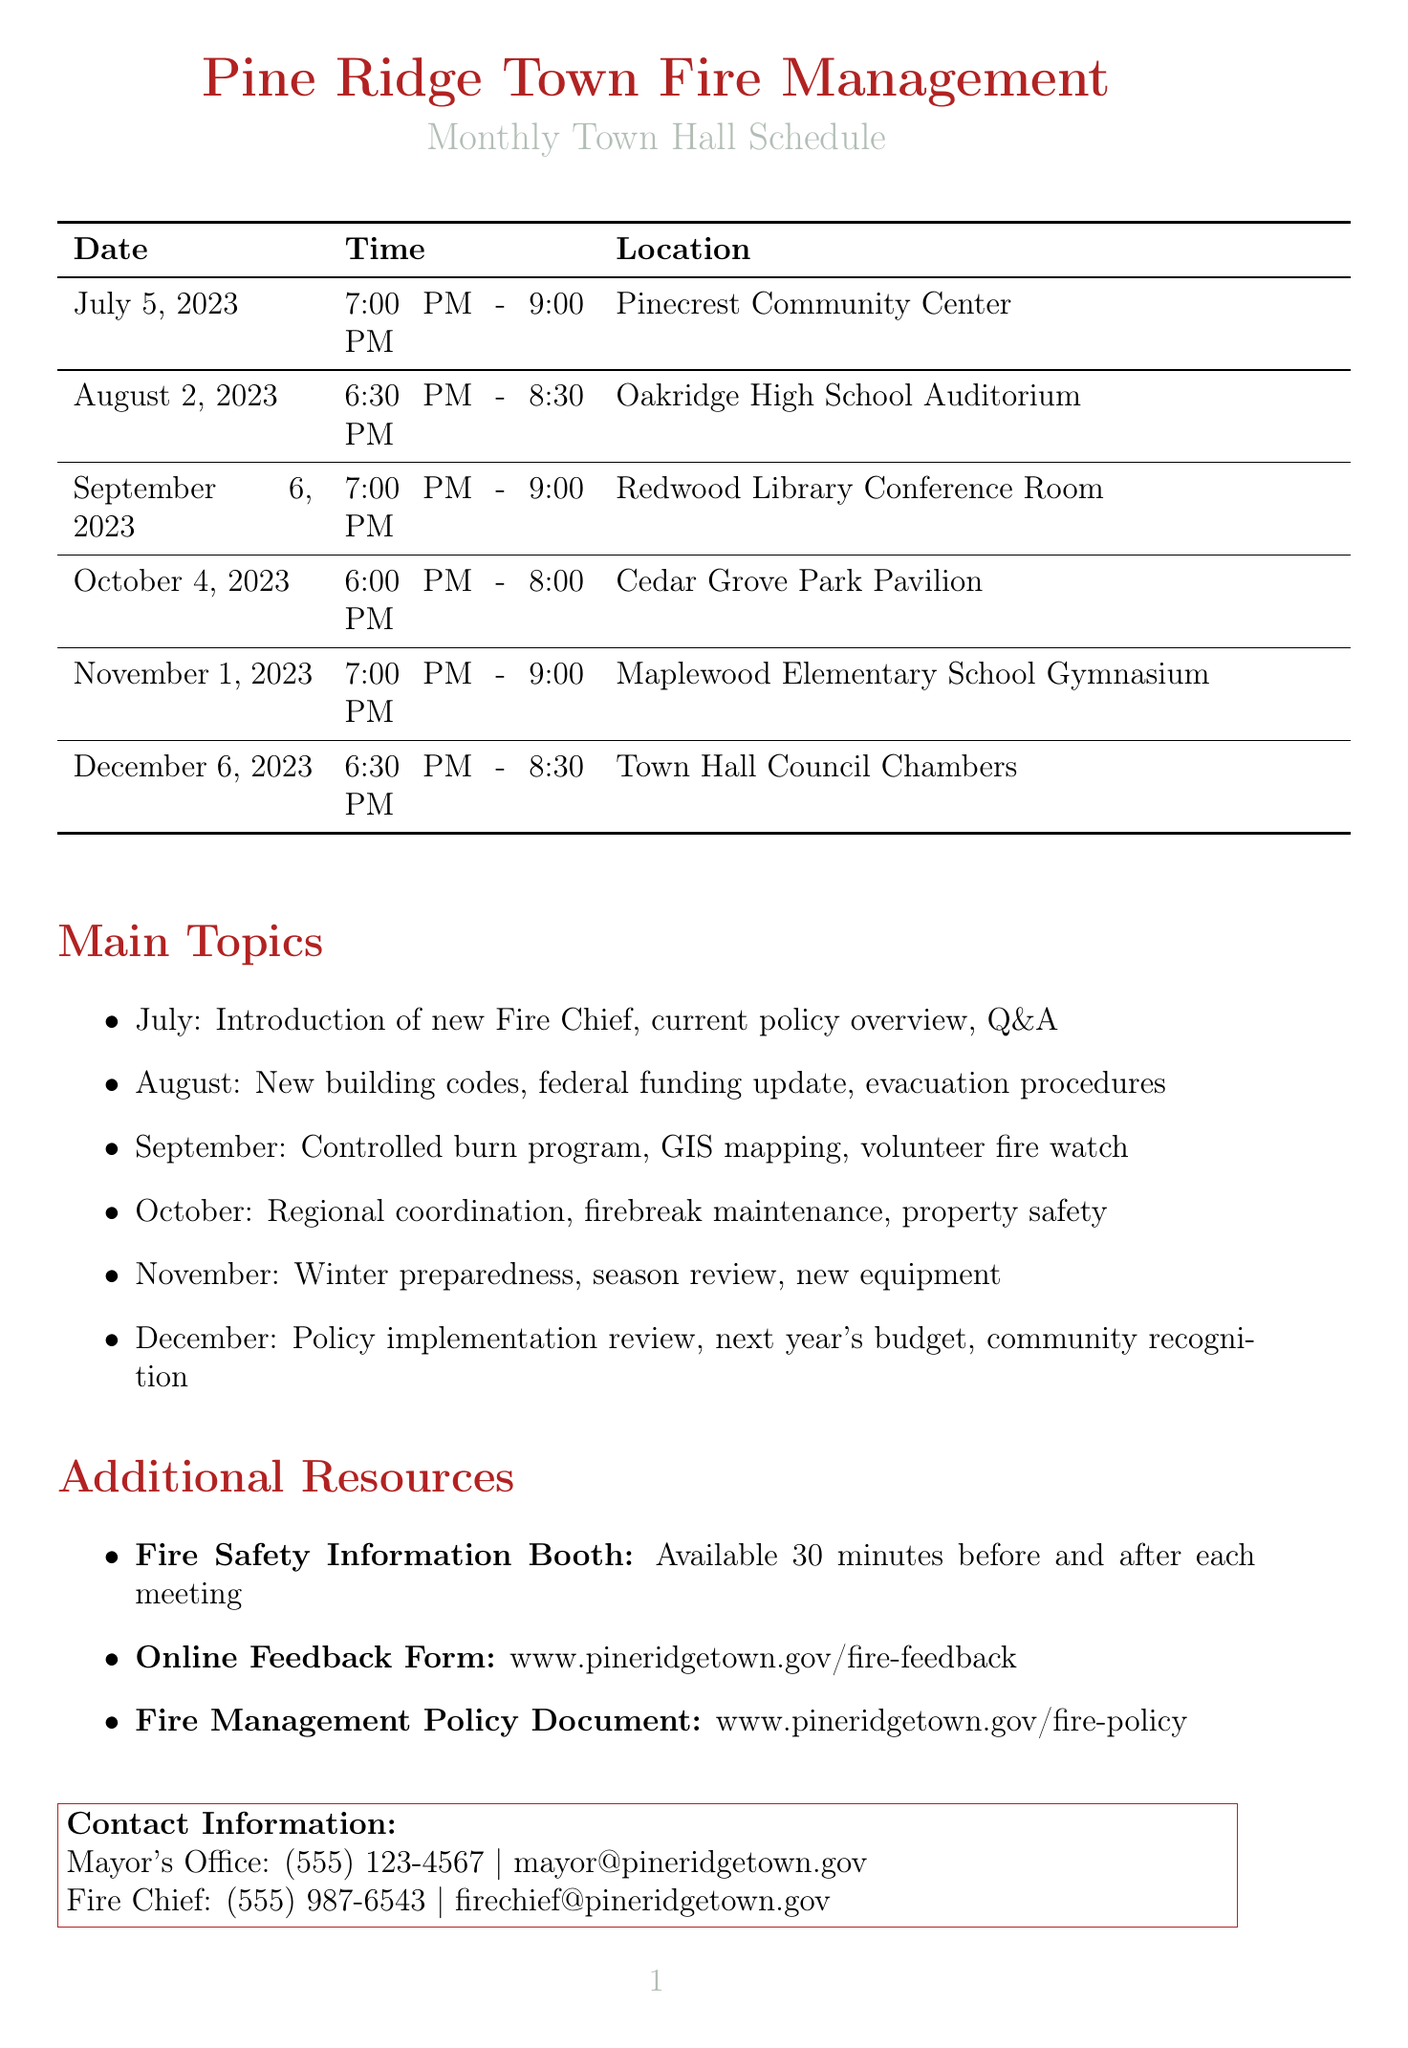What is the date of the October town hall? The date for the October town hall is explicitly stated in the schedule as October 4, 2023.
Answer: October 4, 2023 What is the time for the November town hall? The time for the November town hall is listed in the schedule as 7:00 PM - 9:00 PM.
Answer: 7:00 PM - 9:00 PM Where will the August town hall be held? The location for the August town hall is specified as Oakridge High School Auditorium in the document.
Answer: Oakridge High School Auditorium Who will be introduced in July's town hall? The document mentions the introduction of the new Fire Chief, Sarah Johnson, in July's town hall.
Answer: Sarah Johnson How many meetings are scheduled in 2023? The document lists six distinct meetings scheduled throughout the year 2023.
Answer: Six What is the main topic of the December town hall? The main topic of the December town hall includes a year-end review of fire management policy implementation, as stated in the schedule.
Answer: Year-end review of fire management policy implementation What resource is available before and after each meeting? The document specifies that a Fire Safety Information Booth is available 30 minutes before and after each town hall meeting.
Answer: Fire Safety Information Booth What is the contact email for the mayor's office? The email for the mayor's office is explicitly listed in the document as mayor@pineridgetown.gov.
Answer: mayor@pineridgetown.gov 